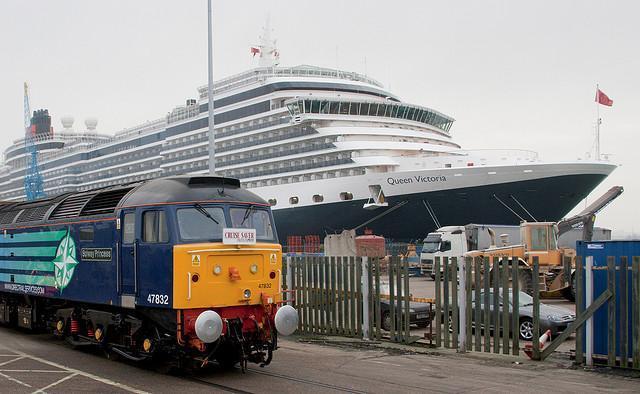How many cars can you see?
Give a very brief answer. 2. 